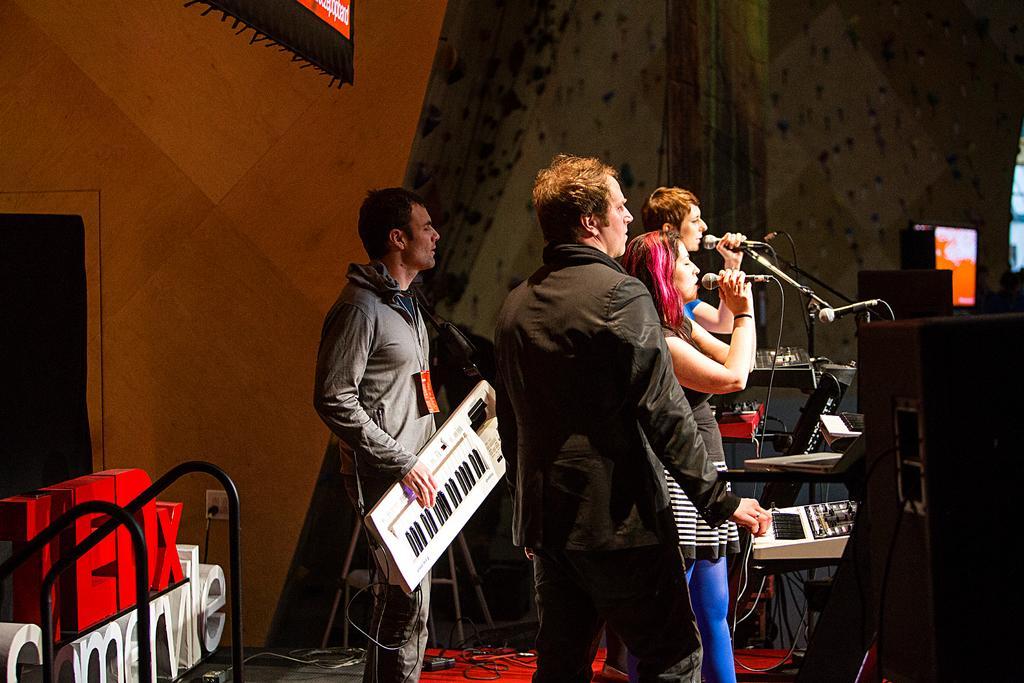Can you describe this image briefly? A band of people playing music on a stage. 